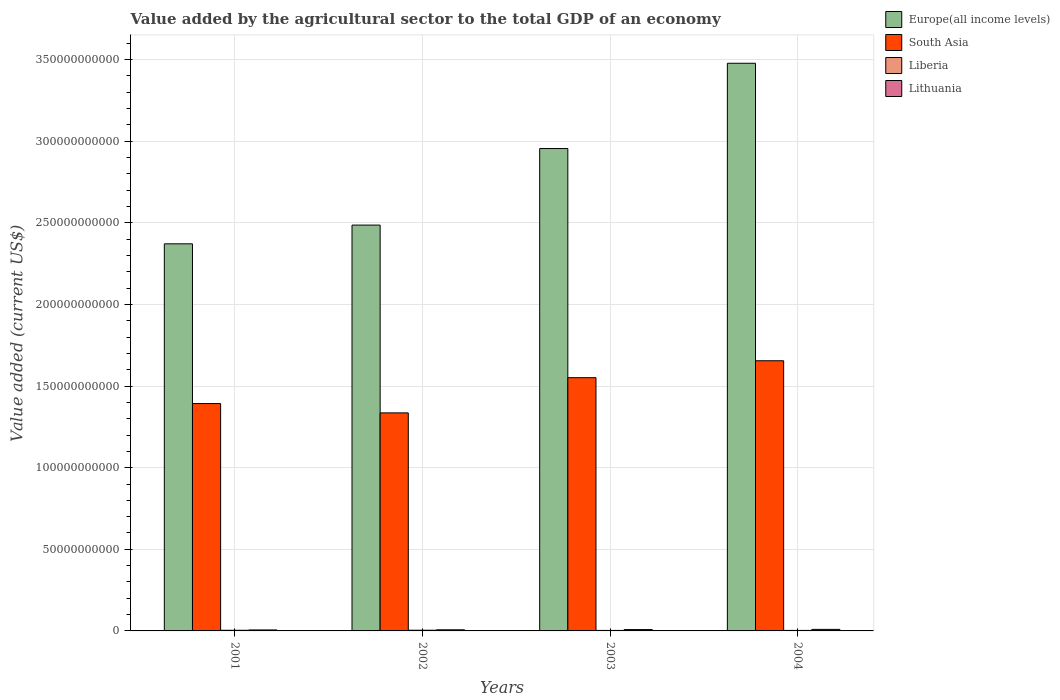How many different coloured bars are there?
Provide a short and direct response. 4. Are the number of bars per tick equal to the number of legend labels?
Keep it short and to the point. Yes. Are the number of bars on each tick of the X-axis equal?
Give a very brief answer. Yes. How many bars are there on the 1st tick from the right?
Your answer should be compact. 4. What is the value added by the agricultural sector to the total GDP in Europe(all income levels) in 2001?
Provide a succinct answer. 2.37e+11. Across all years, what is the maximum value added by the agricultural sector to the total GDP in South Asia?
Your response must be concise. 1.66e+11. Across all years, what is the minimum value added by the agricultural sector to the total GDP in Europe(all income levels)?
Give a very brief answer. 2.37e+11. In which year was the value added by the agricultural sector to the total GDP in Europe(all income levels) maximum?
Ensure brevity in your answer.  2004. In which year was the value added by the agricultural sector to the total GDP in Europe(all income levels) minimum?
Give a very brief answer. 2001. What is the total value added by the agricultural sector to the total GDP in Lithuania in the graph?
Give a very brief answer. 3.05e+09. What is the difference between the value added by the agricultural sector to the total GDP in Lithuania in 2003 and that in 2004?
Your response must be concise. -1.14e+08. What is the difference between the value added by the agricultural sector to the total GDP in South Asia in 2003 and the value added by the agricultural sector to the total GDP in Lithuania in 2002?
Your answer should be compact. 1.54e+11. What is the average value added by the agricultural sector to the total GDP in Liberia per year?
Your answer should be very brief. 3.59e+08. In the year 2004, what is the difference between the value added by the agricultural sector to the total GDP in Liberia and value added by the agricultural sector to the total GDP in Europe(all income levels)?
Keep it short and to the point. -3.47e+11. What is the ratio of the value added by the agricultural sector to the total GDP in Europe(all income levels) in 2002 to that in 2004?
Keep it short and to the point. 0.71. Is the difference between the value added by the agricultural sector to the total GDP in Liberia in 2001 and 2004 greater than the difference between the value added by the agricultural sector to the total GDP in Europe(all income levels) in 2001 and 2004?
Provide a short and direct response. Yes. What is the difference between the highest and the second highest value added by the agricultural sector to the total GDP in Liberia?
Offer a terse response. 3.05e+07. What is the difference between the highest and the lowest value added by the agricultural sector to the total GDP in Lithuania?
Provide a short and direct response. 3.48e+08. In how many years, is the value added by the agricultural sector to the total GDP in South Asia greater than the average value added by the agricultural sector to the total GDP in South Asia taken over all years?
Your answer should be compact. 2. Is it the case that in every year, the sum of the value added by the agricultural sector to the total GDP in South Asia and value added by the agricultural sector to the total GDP in Europe(all income levels) is greater than the sum of value added by the agricultural sector to the total GDP in Lithuania and value added by the agricultural sector to the total GDP in Liberia?
Provide a short and direct response. No. What does the 1st bar from the left in 2004 represents?
Your response must be concise. Europe(all income levels). What does the 2nd bar from the right in 2004 represents?
Your response must be concise. Liberia. Are all the bars in the graph horizontal?
Give a very brief answer. No. Are the values on the major ticks of Y-axis written in scientific E-notation?
Provide a short and direct response. No. Where does the legend appear in the graph?
Provide a succinct answer. Top right. How many legend labels are there?
Your response must be concise. 4. How are the legend labels stacked?
Keep it short and to the point. Vertical. What is the title of the graph?
Your answer should be very brief. Value added by the agricultural sector to the total GDP of an economy. Does "Somalia" appear as one of the legend labels in the graph?
Offer a terse response. No. What is the label or title of the X-axis?
Provide a short and direct response. Years. What is the label or title of the Y-axis?
Keep it short and to the point. Value added (current US$). What is the Value added (current US$) in Europe(all income levels) in 2001?
Ensure brevity in your answer.  2.37e+11. What is the Value added (current US$) in South Asia in 2001?
Ensure brevity in your answer.  1.39e+11. What is the Value added (current US$) in Liberia in 2001?
Your answer should be very brief. 3.99e+08. What is the Value added (current US$) of Lithuania in 2001?
Offer a terse response. 5.96e+08. What is the Value added (current US$) of Europe(all income levels) in 2002?
Your response must be concise. 2.49e+11. What is the Value added (current US$) in South Asia in 2002?
Make the answer very short. 1.34e+11. What is the Value added (current US$) in Liberia in 2002?
Give a very brief answer. 4.29e+08. What is the Value added (current US$) of Lithuania in 2002?
Make the answer very short. 6.81e+08. What is the Value added (current US$) in Europe(all income levels) in 2003?
Provide a short and direct response. 2.96e+11. What is the Value added (current US$) of South Asia in 2003?
Ensure brevity in your answer.  1.55e+11. What is the Value added (current US$) in Liberia in 2003?
Offer a terse response. 3.01e+08. What is the Value added (current US$) in Lithuania in 2003?
Provide a succinct answer. 8.31e+08. What is the Value added (current US$) in Europe(all income levels) in 2004?
Your response must be concise. 3.48e+11. What is the Value added (current US$) in South Asia in 2004?
Offer a terse response. 1.66e+11. What is the Value added (current US$) of Liberia in 2004?
Ensure brevity in your answer.  3.09e+08. What is the Value added (current US$) in Lithuania in 2004?
Offer a terse response. 9.44e+08. Across all years, what is the maximum Value added (current US$) of Europe(all income levels)?
Your answer should be very brief. 3.48e+11. Across all years, what is the maximum Value added (current US$) in South Asia?
Keep it short and to the point. 1.66e+11. Across all years, what is the maximum Value added (current US$) in Liberia?
Give a very brief answer. 4.29e+08. Across all years, what is the maximum Value added (current US$) of Lithuania?
Your answer should be very brief. 9.44e+08. Across all years, what is the minimum Value added (current US$) in Europe(all income levels)?
Your answer should be very brief. 2.37e+11. Across all years, what is the minimum Value added (current US$) in South Asia?
Ensure brevity in your answer.  1.34e+11. Across all years, what is the minimum Value added (current US$) of Liberia?
Your answer should be compact. 3.01e+08. Across all years, what is the minimum Value added (current US$) in Lithuania?
Offer a terse response. 5.96e+08. What is the total Value added (current US$) of Europe(all income levels) in the graph?
Ensure brevity in your answer.  1.13e+12. What is the total Value added (current US$) of South Asia in the graph?
Give a very brief answer. 5.94e+11. What is the total Value added (current US$) of Liberia in the graph?
Provide a succinct answer. 1.44e+09. What is the total Value added (current US$) in Lithuania in the graph?
Provide a short and direct response. 3.05e+09. What is the difference between the Value added (current US$) in Europe(all income levels) in 2001 and that in 2002?
Your answer should be very brief. -1.15e+1. What is the difference between the Value added (current US$) in South Asia in 2001 and that in 2002?
Your answer should be very brief. 5.71e+09. What is the difference between the Value added (current US$) in Liberia in 2001 and that in 2002?
Ensure brevity in your answer.  -3.05e+07. What is the difference between the Value added (current US$) of Lithuania in 2001 and that in 2002?
Give a very brief answer. -8.44e+07. What is the difference between the Value added (current US$) of Europe(all income levels) in 2001 and that in 2003?
Make the answer very short. -5.84e+1. What is the difference between the Value added (current US$) of South Asia in 2001 and that in 2003?
Give a very brief answer. -1.58e+1. What is the difference between the Value added (current US$) of Liberia in 2001 and that in 2003?
Your answer should be very brief. 9.82e+07. What is the difference between the Value added (current US$) of Lithuania in 2001 and that in 2003?
Provide a succinct answer. -2.34e+08. What is the difference between the Value added (current US$) in Europe(all income levels) in 2001 and that in 2004?
Provide a succinct answer. -1.11e+11. What is the difference between the Value added (current US$) of South Asia in 2001 and that in 2004?
Provide a short and direct response. -2.62e+1. What is the difference between the Value added (current US$) of Liberia in 2001 and that in 2004?
Provide a short and direct response. 9.00e+07. What is the difference between the Value added (current US$) in Lithuania in 2001 and that in 2004?
Provide a succinct answer. -3.48e+08. What is the difference between the Value added (current US$) in Europe(all income levels) in 2002 and that in 2003?
Offer a very short reply. -4.69e+1. What is the difference between the Value added (current US$) of South Asia in 2002 and that in 2003?
Your answer should be compact. -2.16e+1. What is the difference between the Value added (current US$) in Liberia in 2002 and that in 2003?
Make the answer very short. 1.29e+08. What is the difference between the Value added (current US$) in Lithuania in 2002 and that in 2003?
Offer a very short reply. -1.50e+08. What is the difference between the Value added (current US$) in Europe(all income levels) in 2002 and that in 2004?
Your answer should be compact. -9.91e+1. What is the difference between the Value added (current US$) in South Asia in 2002 and that in 2004?
Ensure brevity in your answer.  -3.19e+1. What is the difference between the Value added (current US$) of Liberia in 2002 and that in 2004?
Provide a short and direct response. 1.20e+08. What is the difference between the Value added (current US$) of Lithuania in 2002 and that in 2004?
Ensure brevity in your answer.  -2.63e+08. What is the difference between the Value added (current US$) of Europe(all income levels) in 2003 and that in 2004?
Your answer should be compact. -5.23e+1. What is the difference between the Value added (current US$) in South Asia in 2003 and that in 2004?
Make the answer very short. -1.04e+1. What is the difference between the Value added (current US$) of Liberia in 2003 and that in 2004?
Provide a short and direct response. -8.26e+06. What is the difference between the Value added (current US$) in Lithuania in 2003 and that in 2004?
Offer a terse response. -1.14e+08. What is the difference between the Value added (current US$) of Europe(all income levels) in 2001 and the Value added (current US$) of South Asia in 2002?
Ensure brevity in your answer.  1.04e+11. What is the difference between the Value added (current US$) of Europe(all income levels) in 2001 and the Value added (current US$) of Liberia in 2002?
Your answer should be very brief. 2.37e+11. What is the difference between the Value added (current US$) of Europe(all income levels) in 2001 and the Value added (current US$) of Lithuania in 2002?
Keep it short and to the point. 2.36e+11. What is the difference between the Value added (current US$) of South Asia in 2001 and the Value added (current US$) of Liberia in 2002?
Keep it short and to the point. 1.39e+11. What is the difference between the Value added (current US$) of South Asia in 2001 and the Value added (current US$) of Lithuania in 2002?
Offer a terse response. 1.39e+11. What is the difference between the Value added (current US$) in Liberia in 2001 and the Value added (current US$) in Lithuania in 2002?
Offer a terse response. -2.82e+08. What is the difference between the Value added (current US$) in Europe(all income levels) in 2001 and the Value added (current US$) in South Asia in 2003?
Keep it short and to the point. 8.20e+1. What is the difference between the Value added (current US$) of Europe(all income levels) in 2001 and the Value added (current US$) of Liberia in 2003?
Give a very brief answer. 2.37e+11. What is the difference between the Value added (current US$) in Europe(all income levels) in 2001 and the Value added (current US$) in Lithuania in 2003?
Provide a short and direct response. 2.36e+11. What is the difference between the Value added (current US$) of South Asia in 2001 and the Value added (current US$) of Liberia in 2003?
Make the answer very short. 1.39e+11. What is the difference between the Value added (current US$) of South Asia in 2001 and the Value added (current US$) of Lithuania in 2003?
Your answer should be very brief. 1.38e+11. What is the difference between the Value added (current US$) in Liberia in 2001 and the Value added (current US$) in Lithuania in 2003?
Ensure brevity in your answer.  -4.32e+08. What is the difference between the Value added (current US$) in Europe(all income levels) in 2001 and the Value added (current US$) in South Asia in 2004?
Your answer should be compact. 7.16e+1. What is the difference between the Value added (current US$) in Europe(all income levels) in 2001 and the Value added (current US$) in Liberia in 2004?
Make the answer very short. 2.37e+11. What is the difference between the Value added (current US$) in Europe(all income levels) in 2001 and the Value added (current US$) in Lithuania in 2004?
Your answer should be compact. 2.36e+11. What is the difference between the Value added (current US$) in South Asia in 2001 and the Value added (current US$) in Liberia in 2004?
Provide a succinct answer. 1.39e+11. What is the difference between the Value added (current US$) of South Asia in 2001 and the Value added (current US$) of Lithuania in 2004?
Offer a terse response. 1.38e+11. What is the difference between the Value added (current US$) in Liberia in 2001 and the Value added (current US$) in Lithuania in 2004?
Provide a short and direct response. -5.45e+08. What is the difference between the Value added (current US$) in Europe(all income levels) in 2002 and the Value added (current US$) in South Asia in 2003?
Your answer should be very brief. 9.35e+1. What is the difference between the Value added (current US$) in Europe(all income levels) in 2002 and the Value added (current US$) in Liberia in 2003?
Keep it short and to the point. 2.48e+11. What is the difference between the Value added (current US$) of Europe(all income levels) in 2002 and the Value added (current US$) of Lithuania in 2003?
Offer a terse response. 2.48e+11. What is the difference between the Value added (current US$) of South Asia in 2002 and the Value added (current US$) of Liberia in 2003?
Make the answer very short. 1.33e+11. What is the difference between the Value added (current US$) in South Asia in 2002 and the Value added (current US$) in Lithuania in 2003?
Give a very brief answer. 1.33e+11. What is the difference between the Value added (current US$) of Liberia in 2002 and the Value added (current US$) of Lithuania in 2003?
Provide a succinct answer. -4.01e+08. What is the difference between the Value added (current US$) in Europe(all income levels) in 2002 and the Value added (current US$) in South Asia in 2004?
Your answer should be very brief. 8.31e+1. What is the difference between the Value added (current US$) of Europe(all income levels) in 2002 and the Value added (current US$) of Liberia in 2004?
Give a very brief answer. 2.48e+11. What is the difference between the Value added (current US$) of Europe(all income levels) in 2002 and the Value added (current US$) of Lithuania in 2004?
Provide a succinct answer. 2.48e+11. What is the difference between the Value added (current US$) of South Asia in 2002 and the Value added (current US$) of Liberia in 2004?
Ensure brevity in your answer.  1.33e+11. What is the difference between the Value added (current US$) in South Asia in 2002 and the Value added (current US$) in Lithuania in 2004?
Your answer should be very brief. 1.33e+11. What is the difference between the Value added (current US$) of Liberia in 2002 and the Value added (current US$) of Lithuania in 2004?
Keep it short and to the point. -5.15e+08. What is the difference between the Value added (current US$) of Europe(all income levels) in 2003 and the Value added (current US$) of South Asia in 2004?
Your response must be concise. 1.30e+11. What is the difference between the Value added (current US$) of Europe(all income levels) in 2003 and the Value added (current US$) of Liberia in 2004?
Offer a very short reply. 2.95e+11. What is the difference between the Value added (current US$) in Europe(all income levels) in 2003 and the Value added (current US$) in Lithuania in 2004?
Give a very brief answer. 2.95e+11. What is the difference between the Value added (current US$) of South Asia in 2003 and the Value added (current US$) of Liberia in 2004?
Offer a very short reply. 1.55e+11. What is the difference between the Value added (current US$) in South Asia in 2003 and the Value added (current US$) in Lithuania in 2004?
Offer a very short reply. 1.54e+11. What is the difference between the Value added (current US$) of Liberia in 2003 and the Value added (current US$) of Lithuania in 2004?
Offer a very short reply. -6.44e+08. What is the average Value added (current US$) in Europe(all income levels) per year?
Keep it short and to the point. 2.82e+11. What is the average Value added (current US$) of South Asia per year?
Offer a very short reply. 1.48e+11. What is the average Value added (current US$) in Liberia per year?
Keep it short and to the point. 3.59e+08. What is the average Value added (current US$) in Lithuania per year?
Ensure brevity in your answer.  7.63e+08. In the year 2001, what is the difference between the Value added (current US$) of Europe(all income levels) and Value added (current US$) of South Asia?
Offer a terse response. 9.79e+1. In the year 2001, what is the difference between the Value added (current US$) of Europe(all income levels) and Value added (current US$) of Liberia?
Offer a very short reply. 2.37e+11. In the year 2001, what is the difference between the Value added (current US$) in Europe(all income levels) and Value added (current US$) in Lithuania?
Your response must be concise. 2.37e+11. In the year 2001, what is the difference between the Value added (current US$) in South Asia and Value added (current US$) in Liberia?
Provide a short and direct response. 1.39e+11. In the year 2001, what is the difference between the Value added (current US$) of South Asia and Value added (current US$) of Lithuania?
Make the answer very short. 1.39e+11. In the year 2001, what is the difference between the Value added (current US$) in Liberia and Value added (current US$) in Lithuania?
Your answer should be compact. -1.98e+08. In the year 2002, what is the difference between the Value added (current US$) in Europe(all income levels) and Value added (current US$) in South Asia?
Keep it short and to the point. 1.15e+11. In the year 2002, what is the difference between the Value added (current US$) of Europe(all income levels) and Value added (current US$) of Liberia?
Provide a short and direct response. 2.48e+11. In the year 2002, what is the difference between the Value added (current US$) of Europe(all income levels) and Value added (current US$) of Lithuania?
Your answer should be compact. 2.48e+11. In the year 2002, what is the difference between the Value added (current US$) of South Asia and Value added (current US$) of Liberia?
Provide a short and direct response. 1.33e+11. In the year 2002, what is the difference between the Value added (current US$) of South Asia and Value added (current US$) of Lithuania?
Keep it short and to the point. 1.33e+11. In the year 2002, what is the difference between the Value added (current US$) in Liberia and Value added (current US$) in Lithuania?
Provide a short and direct response. -2.52e+08. In the year 2003, what is the difference between the Value added (current US$) of Europe(all income levels) and Value added (current US$) of South Asia?
Your answer should be very brief. 1.40e+11. In the year 2003, what is the difference between the Value added (current US$) in Europe(all income levels) and Value added (current US$) in Liberia?
Keep it short and to the point. 2.95e+11. In the year 2003, what is the difference between the Value added (current US$) of Europe(all income levels) and Value added (current US$) of Lithuania?
Offer a very short reply. 2.95e+11. In the year 2003, what is the difference between the Value added (current US$) of South Asia and Value added (current US$) of Liberia?
Your answer should be very brief. 1.55e+11. In the year 2003, what is the difference between the Value added (current US$) in South Asia and Value added (current US$) in Lithuania?
Offer a very short reply. 1.54e+11. In the year 2003, what is the difference between the Value added (current US$) in Liberia and Value added (current US$) in Lithuania?
Your response must be concise. -5.30e+08. In the year 2004, what is the difference between the Value added (current US$) of Europe(all income levels) and Value added (current US$) of South Asia?
Your response must be concise. 1.82e+11. In the year 2004, what is the difference between the Value added (current US$) in Europe(all income levels) and Value added (current US$) in Liberia?
Keep it short and to the point. 3.47e+11. In the year 2004, what is the difference between the Value added (current US$) in Europe(all income levels) and Value added (current US$) in Lithuania?
Make the answer very short. 3.47e+11. In the year 2004, what is the difference between the Value added (current US$) in South Asia and Value added (current US$) in Liberia?
Your answer should be compact. 1.65e+11. In the year 2004, what is the difference between the Value added (current US$) in South Asia and Value added (current US$) in Lithuania?
Offer a terse response. 1.65e+11. In the year 2004, what is the difference between the Value added (current US$) of Liberia and Value added (current US$) of Lithuania?
Provide a short and direct response. -6.35e+08. What is the ratio of the Value added (current US$) of Europe(all income levels) in 2001 to that in 2002?
Give a very brief answer. 0.95. What is the ratio of the Value added (current US$) in South Asia in 2001 to that in 2002?
Your answer should be compact. 1.04. What is the ratio of the Value added (current US$) in Liberia in 2001 to that in 2002?
Your response must be concise. 0.93. What is the ratio of the Value added (current US$) of Lithuania in 2001 to that in 2002?
Ensure brevity in your answer.  0.88. What is the ratio of the Value added (current US$) of Europe(all income levels) in 2001 to that in 2003?
Your response must be concise. 0.8. What is the ratio of the Value added (current US$) of South Asia in 2001 to that in 2003?
Your answer should be very brief. 0.9. What is the ratio of the Value added (current US$) of Liberia in 2001 to that in 2003?
Your answer should be compact. 1.33. What is the ratio of the Value added (current US$) in Lithuania in 2001 to that in 2003?
Your answer should be compact. 0.72. What is the ratio of the Value added (current US$) of Europe(all income levels) in 2001 to that in 2004?
Give a very brief answer. 0.68. What is the ratio of the Value added (current US$) in South Asia in 2001 to that in 2004?
Provide a succinct answer. 0.84. What is the ratio of the Value added (current US$) in Liberia in 2001 to that in 2004?
Provide a short and direct response. 1.29. What is the ratio of the Value added (current US$) of Lithuania in 2001 to that in 2004?
Your answer should be very brief. 0.63. What is the ratio of the Value added (current US$) of Europe(all income levels) in 2002 to that in 2003?
Your response must be concise. 0.84. What is the ratio of the Value added (current US$) of South Asia in 2002 to that in 2003?
Make the answer very short. 0.86. What is the ratio of the Value added (current US$) in Liberia in 2002 to that in 2003?
Your answer should be compact. 1.43. What is the ratio of the Value added (current US$) of Lithuania in 2002 to that in 2003?
Give a very brief answer. 0.82. What is the ratio of the Value added (current US$) in Europe(all income levels) in 2002 to that in 2004?
Offer a terse response. 0.71. What is the ratio of the Value added (current US$) in South Asia in 2002 to that in 2004?
Offer a very short reply. 0.81. What is the ratio of the Value added (current US$) of Liberia in 2002 to that in 2004?
Your answer should be very brief. 1.39. What is the ratio of the Value added (current US$) in Lithuania in 2002 to that in 2004?
Keep it short and to the point. 0.72. What is the ratio of the Value added (current US$) in Europe(all income levels) in 2003 to that in 2004?
Provide a succinct answer. 0.85. What is the ratio of the Value added (current US$) in South Asia in 2003 to that in 2004?
Keep it short and to the point. 0.94. What is the ratio of the Value added (current US$) in Liberia in 2003 to that in 2004?
Your response must be concise. 0.97. What is the ratio of the Value added (current US$) in Lithuania in 2003 to that in 2004?
Provide a short and direct response. 0.88. What is the difference between the highest and the second highest Value added (current US$) in Europe(all income levels)?
Make the answer very short. 5.23e+1. What is the difference between the highest and the second highest Value added (current US$) of South Asia?
Offer a terse response. 1.04e+1. What is the difference between the highest and the second highest Value added (current US$) in Liberia?
Offer a terse response. 3.05e+07. What is the difference between the highest and the second highest Value added (current US$) of Lithuania?
Make the answer very short. 1.14e+08. What is the difference between the highest and the lowest Value added (current US$) in Europe(all income levels)?
Provide a short and direct response. 1.11e+11. What is the difference between the highest and the lowest Value added (current US$) of South Asia?
Keep it short and to the point. 3.19e+1. What is the difference between the highest and the lowest Value added (current US$) of Liberia?
Make the answer very short. 1.29e+08. What is the difference between the highest and the lowest Value added (current US$) of Lithuania?
Make the answer very short. 3.48e+08. 